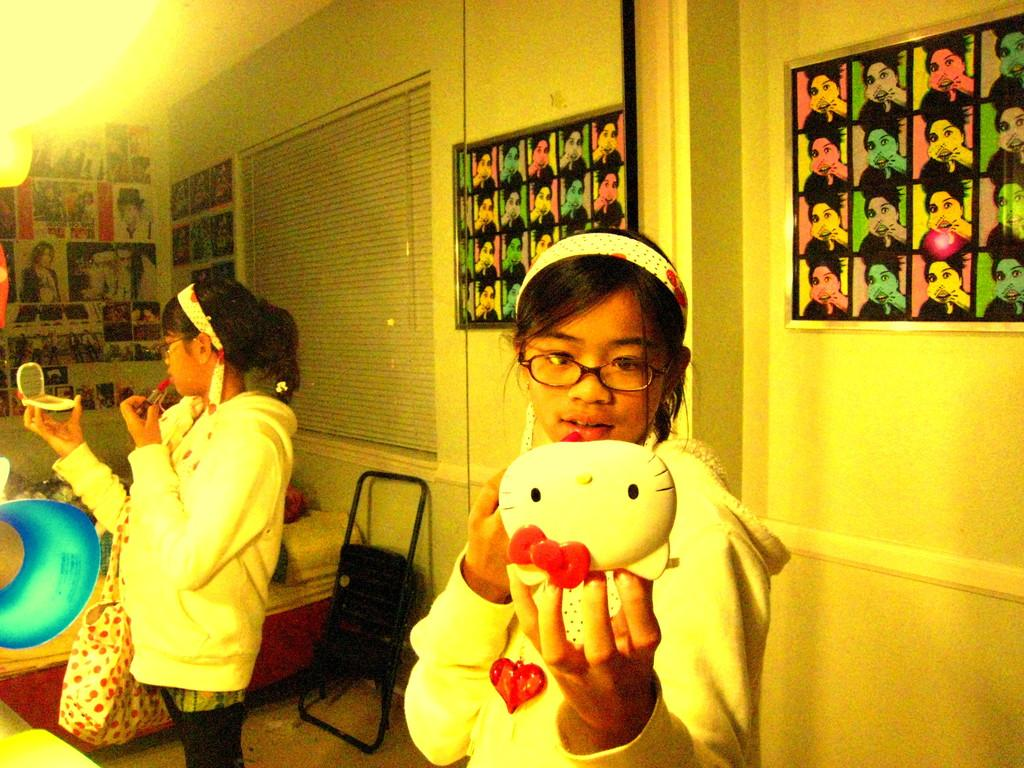What color is the wall in the image? The wall in the image is yellow. What objects can be seen on the wall? There are photo frames on the wall in the image. What architectural feature is present in the image? There is a window in the image. What reflective object is present in the image? There is a mirror in the image. What is the woman holding in the image? The woman is holding a toy in the image. What can be seen in the mirror's reflection? There is a reflection of a bed and a chair in the image. What type of linen can be seen draped over the bed in the image? There is no linen present in the image. --- Facts: 1. There is a car in the image. 2. The car is red. 3. There are people in the car. 4. The car has four doors. 5. The car has a sunroof. Absurd Topics: unicorn, rainbow, thunderstorm Conversation: What is the main subject in the image? There is a car in the image. What color is the car? The car is red. How many people are in the car? There are people in the car. How many doors does the car have? The car has four doors. What special feature does the car have? The car has a sunroof. Reasoning: Let's think step by step in order to produce the conversation. We start by identifying the main subject in the image, which is the car. Then, we describe specific features of the car, such as its color, the number of doors, and the presence of a sunroof. We also mention the presence of people inside the car. Each question is designed to elicit a specific detail about the image that is known from the provided facts. Absurd Question/Answer: Can you see a unicorn standing next to the red car in the image? There is no unicorn present in the image. --- Facts: 1. There is a group of people in the image. 2. The people are wearing hats. 3. The people are holding umbrellas. 4. The people are standing in front of a building. 5. The building has a sign on it. Absurd Topics: elephant, giraffe, zebra Conversation: How many people are in the group in the image? There is a group of people in the image. What type of headwear are the people wearing? The people are wearing hats. What type of accessory are the people holding? The people are holding umbrellas. Where are the people standing in the image? The people are standing in front of a building. What can be seen on the building in the image? The building has 